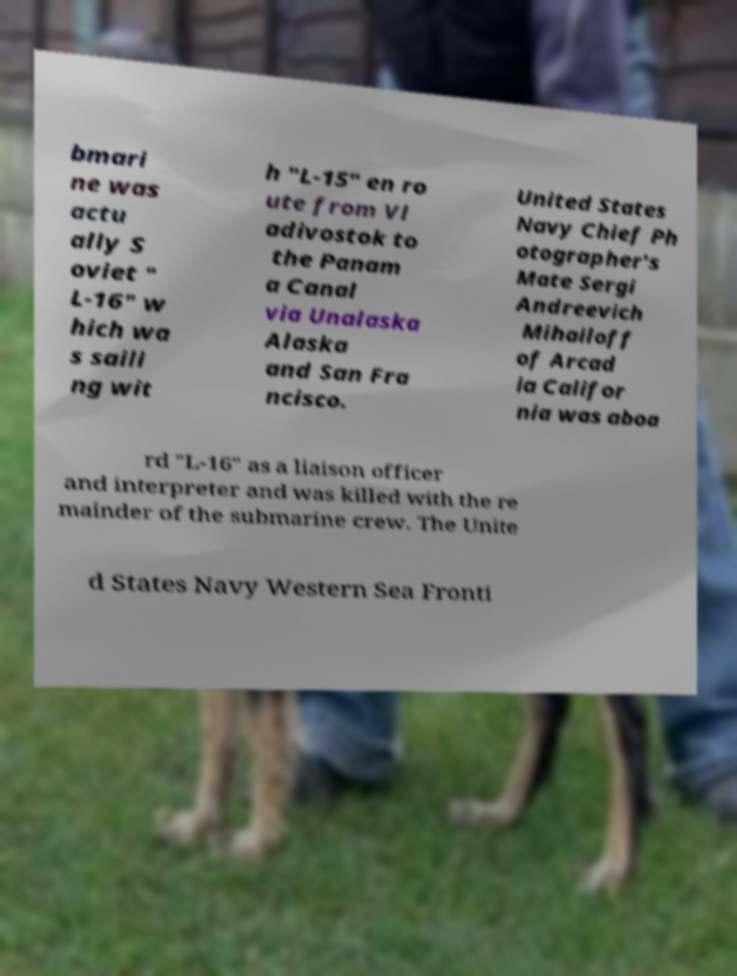What messages or text are displayed in this image? I need them in a readable, typed format. bmari ne was actu ally S oviet " L-16" w hich wa s saili ng wit h "L-15" en ro ute from Vl adivostok to the Panam a Canal via Unalaska Alaska and San Fra ncisco. United States Navy Chief Ph otographer's Mate Sergi Andreevich Mihailoff of Arcad ia Califor nia was aboa rd "L-16" as a liaison officer and interpreter and was killed with the re mainder of the submarine crew. The Unite d States Navy Western Sea Fronti 